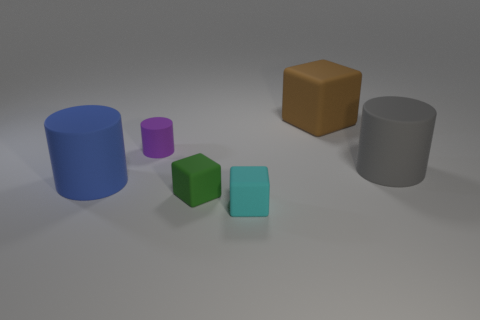Is the size of the gray rubber cylinder the same as the cube behind the big gray thing?
Offer a terse response. Yes. Are there any tiny cyan things behind the big matte cylinder in front of the matte cylinder right of the big cube?
Ensure brevity in your answer.  No. There is a cylinder that is to the left of the cylinder behind the gray rubber cylinder; what is it made of?
Provide a succinct answer. Rubber. What material is the big object that is behind the big blue rubber object and in front of the large brown matte block?
Your response must be concise. Rubber. Is there a cyan object that has the same shape as the green rubber object?
Your answer should be compact. Yes. There is a matte thing to the right of the big rubber block; is there a cylinder that is in front of it?
Your response must be concise. Yes. What number of gray cylinders are made of the same material as the gray object?
Your response must be concise. 0. Are any tiny cyan rubber things visible?
Make the answer very short. Yes. What number of large rubber objects have the same color as the small matte cylinder?
Your response must be concise. 0. Do the cyan object and the large object that is behind the tiny matte cylinder have the same material?
Keep it short and to the point. Yes. 